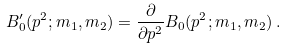Convert formula to latex. <formula><loc_0><loc_0><loc_500><loc_500>B ^ { \prime } _ { 0 } ( p ^ { 2 } ; m _ { 1 } , m _ { 2 } ) = \frac { \partial } { \partial p ^ { 2 } } B _ { 0 } ( p ^ { 2 } ; m _ { 1 } , m _ { 2 } ) \, .</formula> 